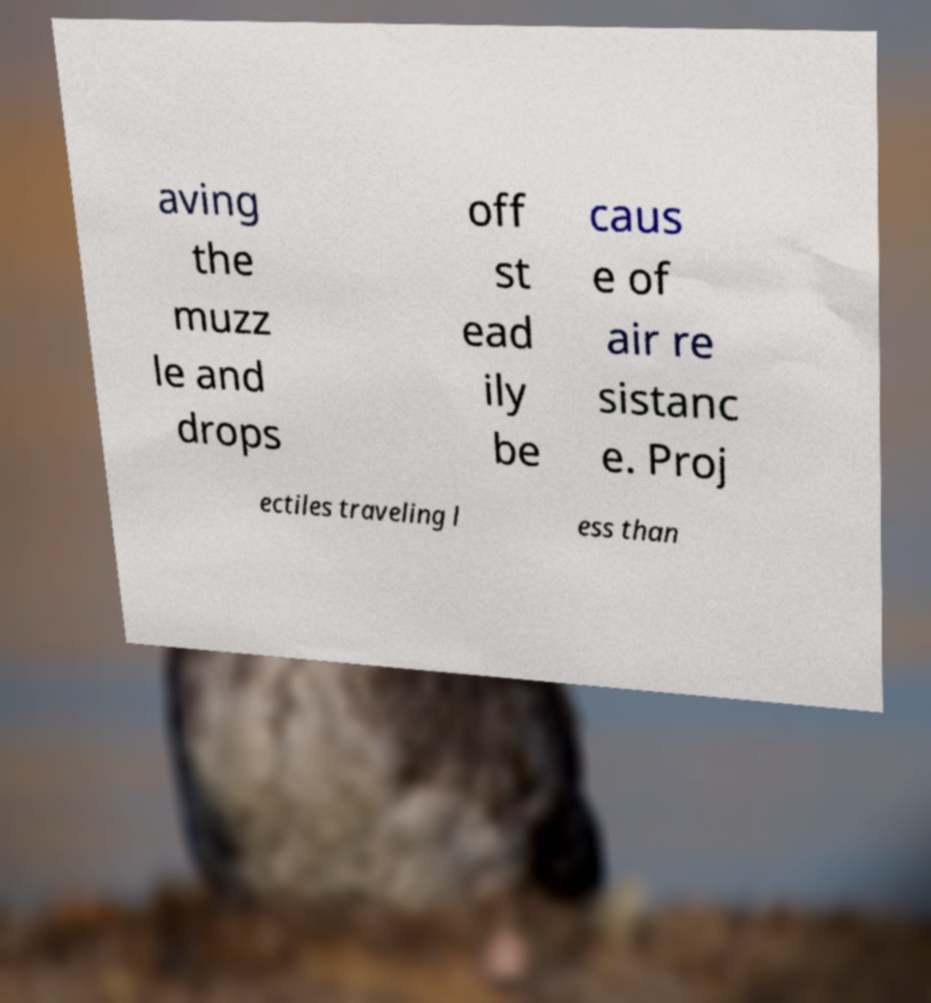There's text embedded in this image that I need extracted. Can you transcribe it verbatim? aving the muzz le and drops off st ead ily be caus e of air re sistanc e. Proj ectiles traveling l ess than 